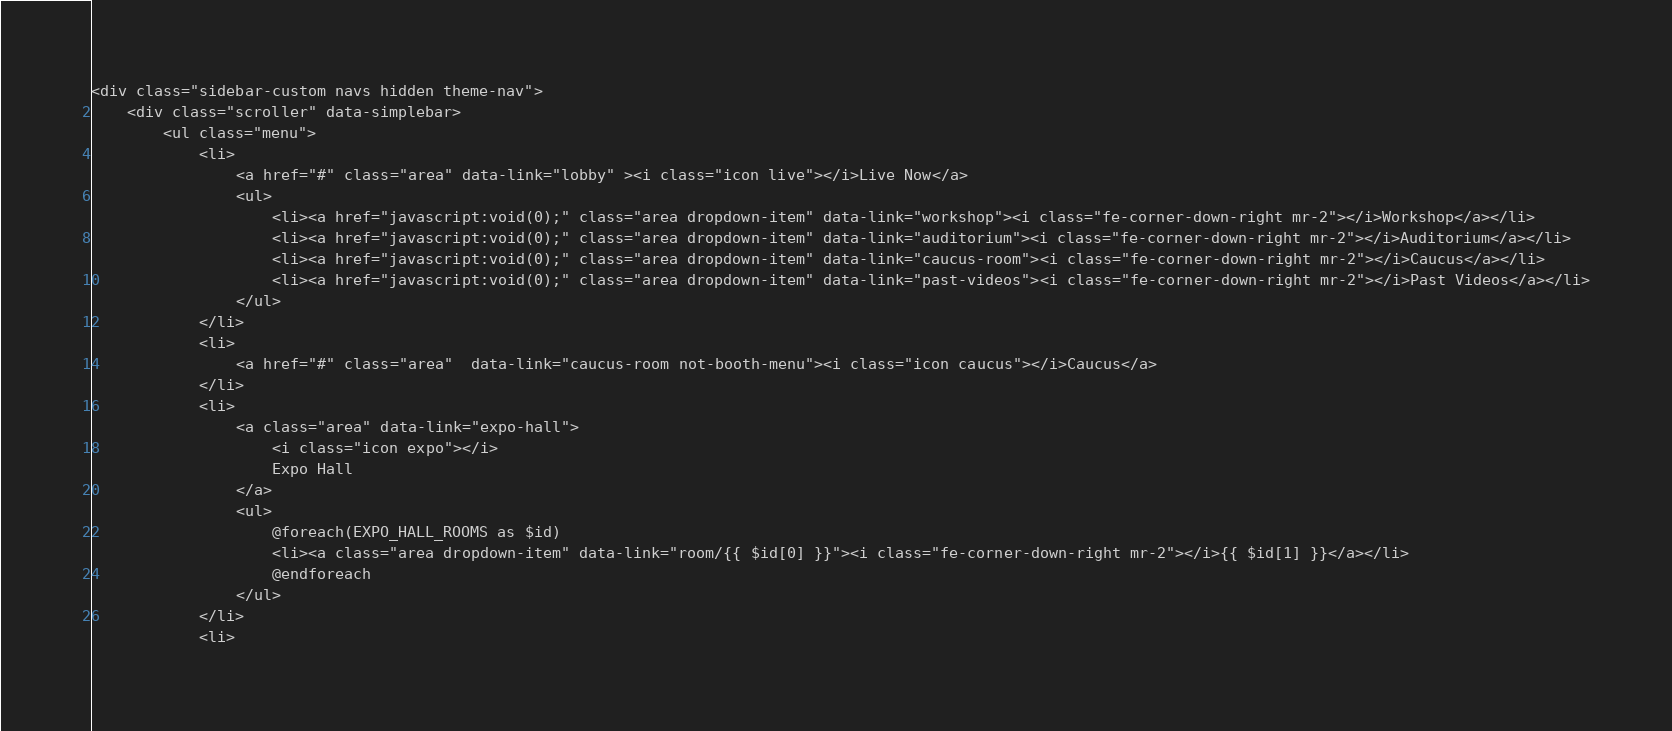<code> <loc_0><loc_0><loc_500><loc_500><_PHP_><div class="sidebar-custom navs hidden theme-nav">
    <div class="scroller" data-simplebar>
        <ul class="menu">
            <li>
                <a href="#" class="area" data-link="lobby" ><i class="icon live"></i>Live Now</a>
                <ul>
                    <li><a href="javascript:void(0);" class="area dropdown-item" data-link="workshop"><i class="fe-corner-down-right mr-2"></i>Workshop</a></li>
                    <li><a href="javascript:void(0);" class="area dropdown-item" data-link="auditorium"><i class="fe-corner-down-right mr-2"></i>Auditorium</a></li>
                    <li><a href="javascript:void(0);" class="area dropdown-item" data-link="caucus-room"><i class="fe-corner-down-right mr-2"></i>Caucus</a></li>
                    <li><a href="javascript:void(0);" class="area dropdown-item" data-link="past-videos"><i class="fe-corner-down-right mr-2"></i>Past Videos</a></li>
                </ul>
            </li>
            <li>
                <a href="#" class="area"  data-link="caucus-room not-booth-menu"><i class="icon caucus"></i>Caucus</a>
            </li>
            <li>
                <a class="area" data-link="expo-hall">
                    <i class="icon expo"></i>
                    Expo Hall
                </a>
                <ul>
                    @foreach(EXPO_HALL_ROOMS as $id)
                    <li><a class="area dropdown-item" data-link="room/{{ $id[0] }}"><i class="fe-corner-down-right mr-2"></i>{{ $id[1] }}</a></li>
                    @endforeach
                </ul>
            </li>
            <li></code> 